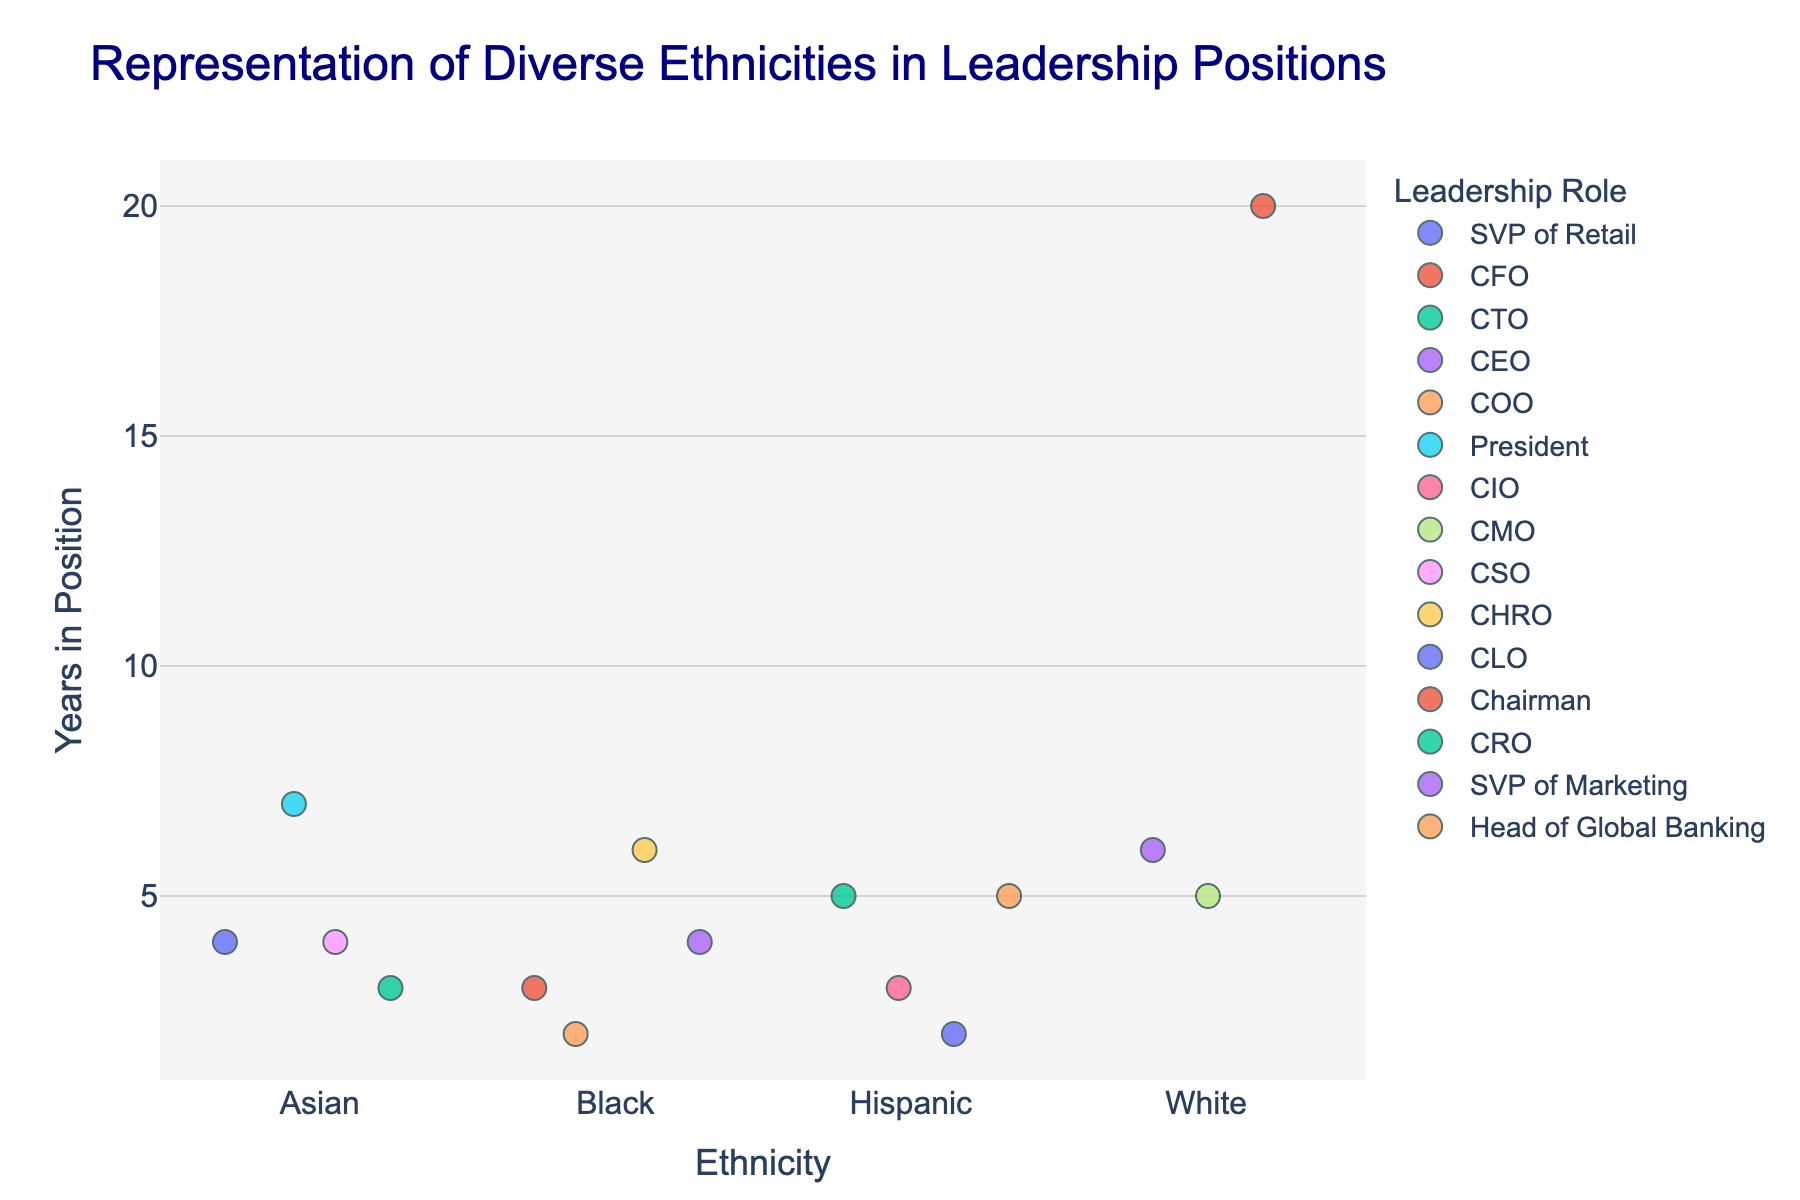What's the title of the figure? The title can be found at the top of the plot and provides an overall description of the data being visualized.
Answer: Representation of Diverse Ethnicities in Leadership Positions What is the highest number of years a leader has been in position for any ethnicity? Look at the y-axis for the maximum value across all data points. The highest point on the y-axis, regardless of color, gives this information.
Answer: 20 years How many ethnicities are represented in the figure? Count the distinct categories along the x-axis; each category corresponds to a different ethnicity.
Answer: 4 Which ethnicity has the most representation in leadership roles across companies? Count the number of data points for each ethnicity and determine which one has the most points.
Answer: Asian What is the average number of years in position for Hispanic leaders? Identify the years in position for each Hispanic leader and calculate their average. (5 + 3 + 2 + 5) / 4 = 3.75
Answer: 3.75 years Which company has the longest-serving leader, and what is their role? Locate the data point at the highest y-axis value and check the associated company and leadership role from the hover data.
Answer: Berkshire Hathaway, Chairman Who are the leaders from the Black ethnicity and their respective roles? Check the data points under the 'Black' category and read the hover data for their roles.
Answer: CFO (Microsoft), COO (JPMorgan Chase), CHRO (Procter & Gamble), SVP of Marketing (Home Depot) Compare the average number of years in position between Asian and White leaders. Calculate the average years in position for both Asian (4, 7, 4, 3) and White leaders (6, 5, 20). Asian: (4 + 7 + 4 + 3) / 4 = 4.5, White: (6 + 5 + 20) / 3 = 10.33
Answer: Asian: 4.5 years, White: 10.33 years Which leadership role has the most diversity in terms of ethnicity? Determine the leadership role with data points across the most ethnic categories. Check the hover data for each role to see their diversity.
Answer: SVP (2 Black, 1 Asian) Is there any ethnicity that does not have a leader with more than 5 years in position? Check for each ethnicity if they have at least one data point above 5 years on the y-axis.
Answer: Hispanic 